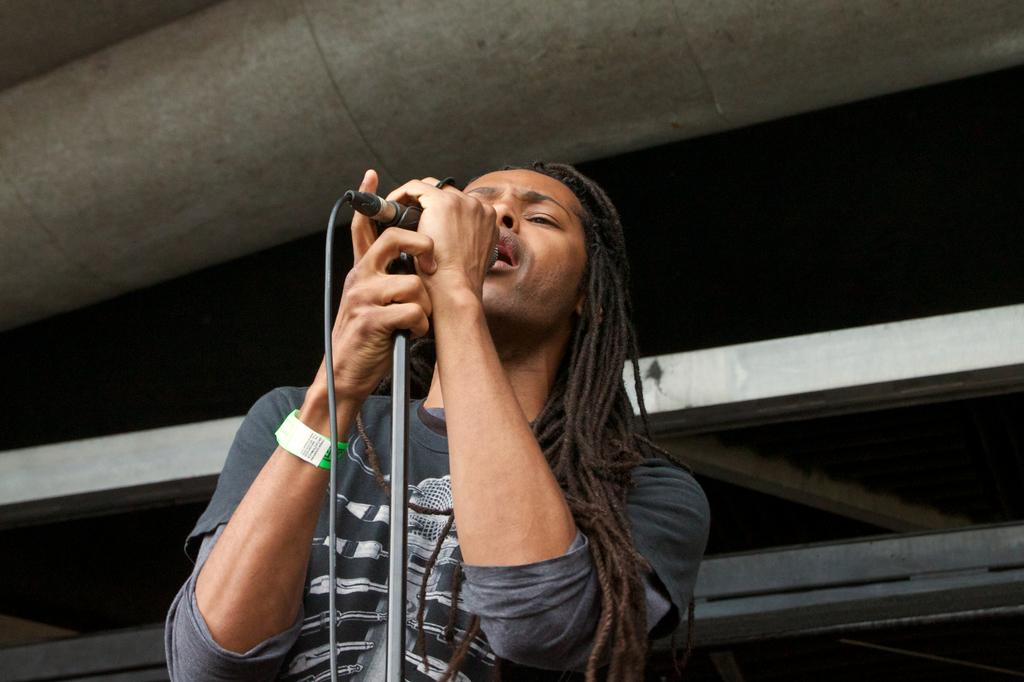What is the person in the image doing? The person is singing a song. What object is the person holding in the image? The person is holding a microphone. What color is the shirt the person is wearing? The person is wearing an ash-colored shirt. What can be observed about the weather in the image? The background of the image is cloudy. Can you hear the person singing in the image? The image is a still photograph, so it does not capture sound. Therefore, we cannot hear the person singing in the image. How many people are running in the image? There is no indication of anyone running in the image; the person is singing while holding a microphone. 